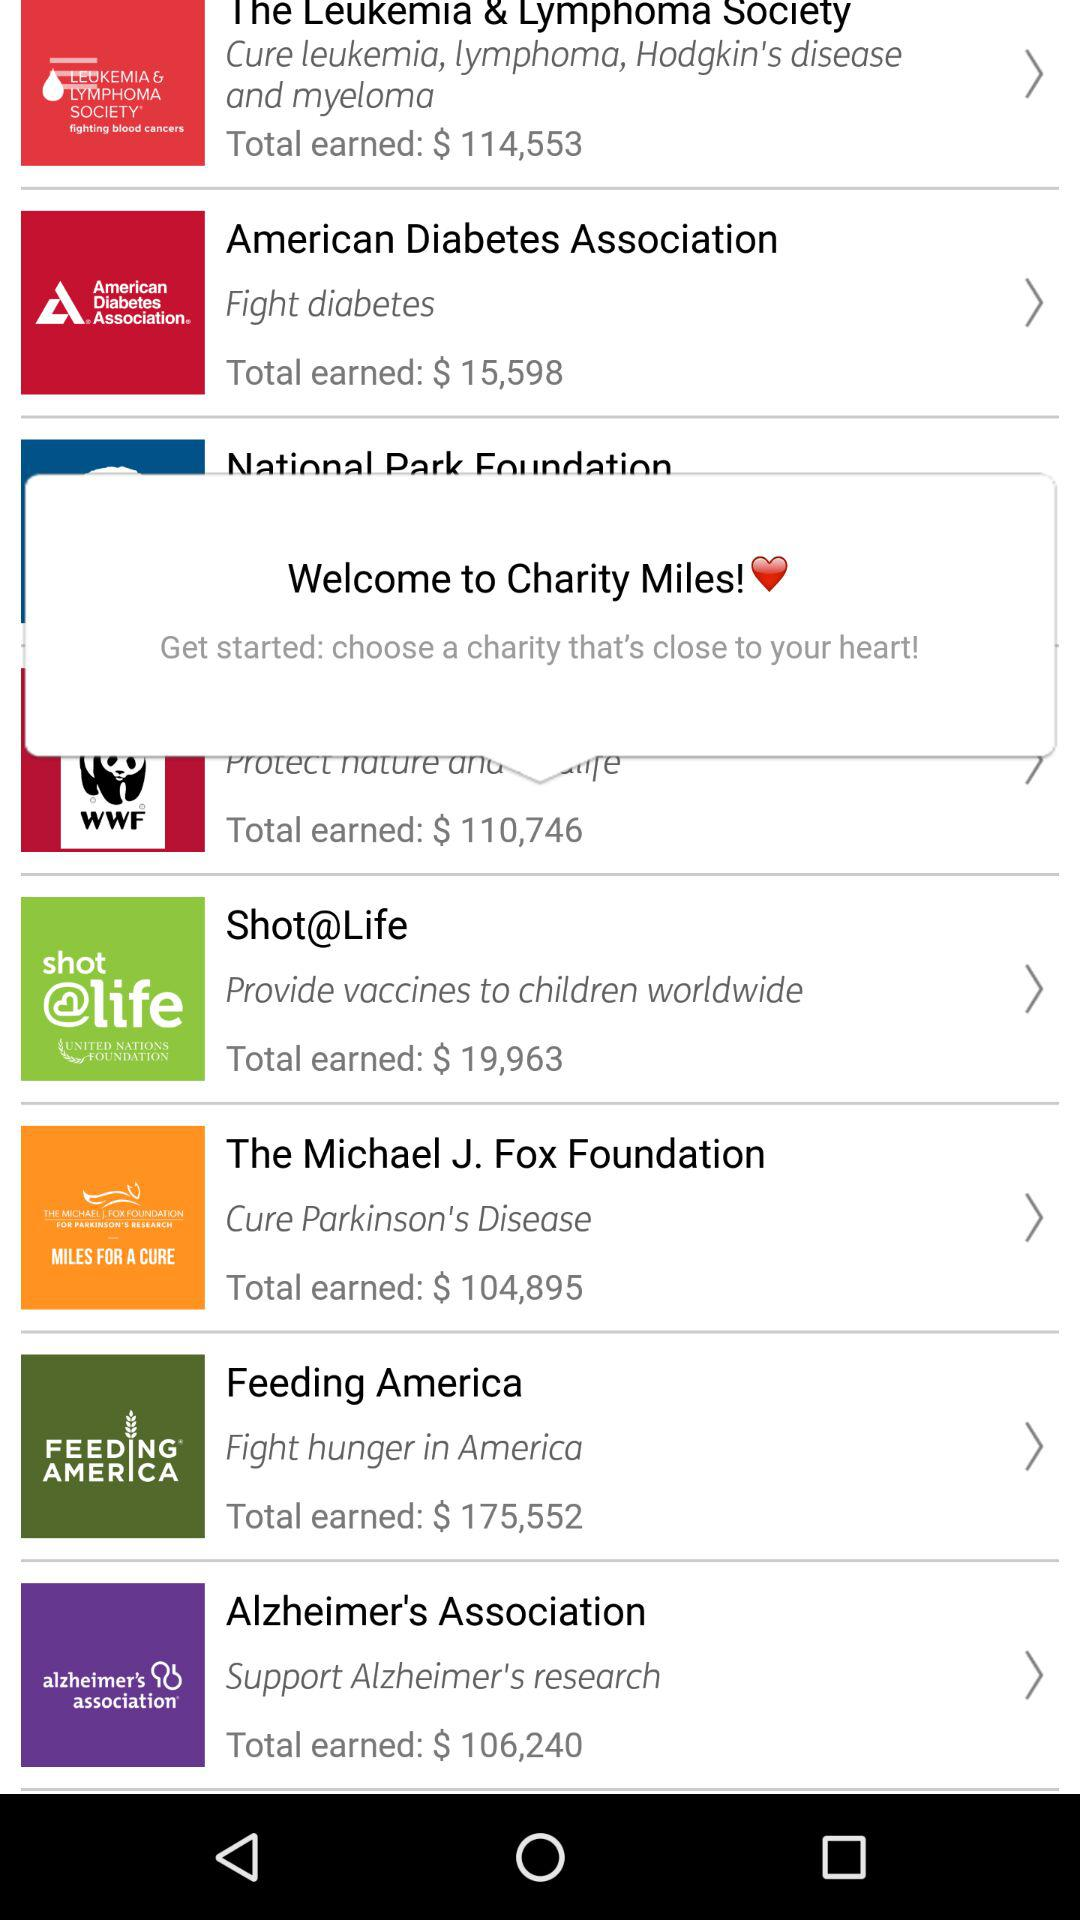What is the name of the organization that provides free vaccines for children worldwide? The name of the organization is "Shot@Life". 